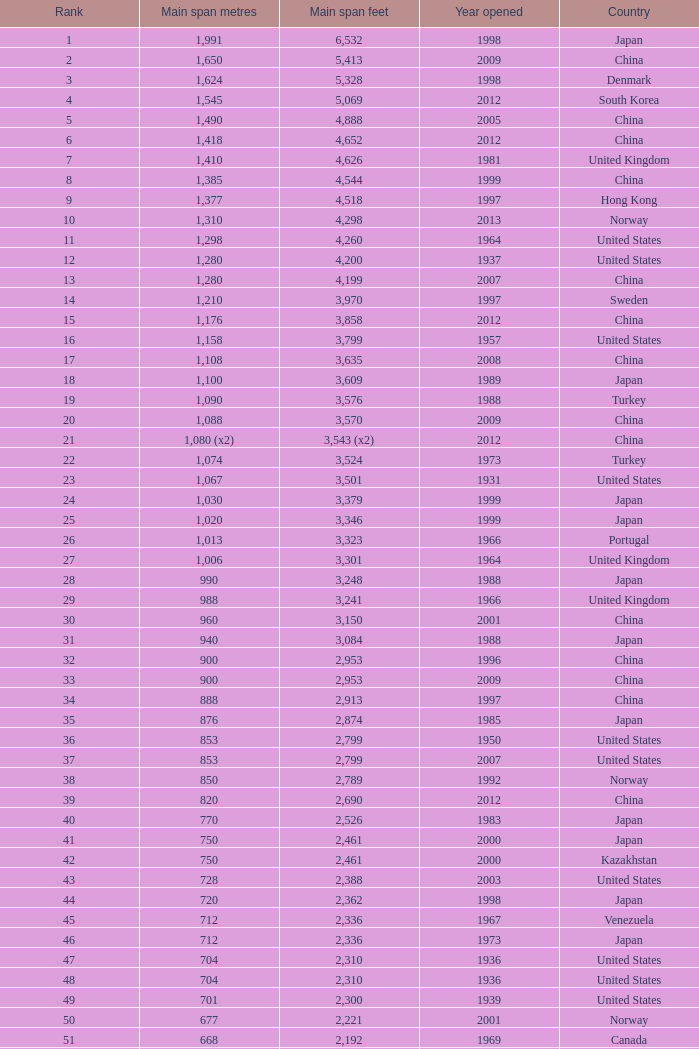What was the first year in south korea when a main span of 1,640 feet was recorded? 2002.0. 